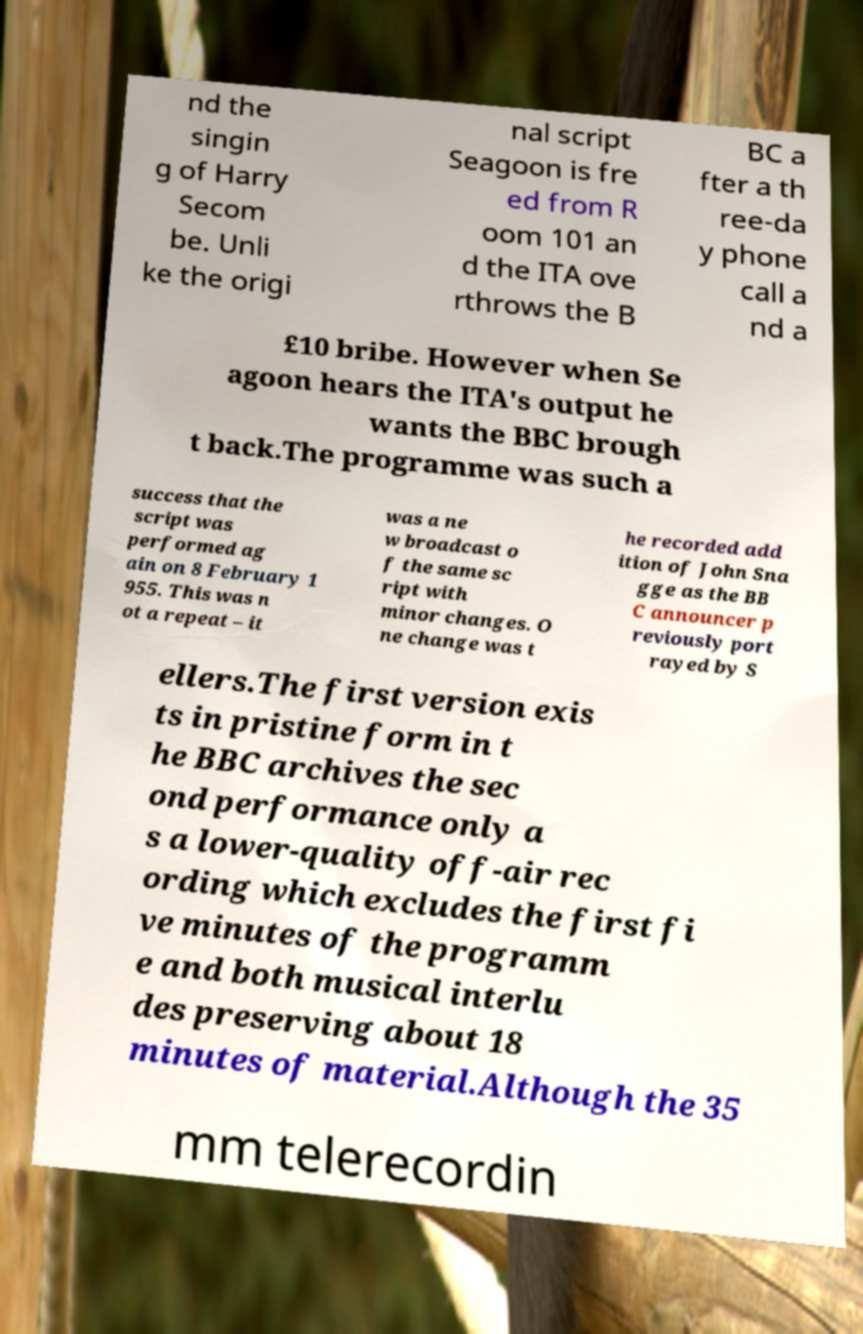I need the written content from this picture converted into text. Can you do that? nd the singin g of Harry Secom be. Unli ke the origi nal script Seagoon is fre ed from R oom 101 an d the ITA ove rthrows the B BC a fter a th ree-da y phone call a nd a £10 bribe. However when Se agoon hears the ITA's output he wants the BBC brough t back.The programme was such a success that the script was performed ag ain on 8 February 1 955. This was n ot a repeat – it was a ne w broadcast o f the same sc ript with minor changes. O ne change was t he recorded add ition of John Sna gge as the BB C announcer p reviously port rayed by S ellers.The first version exis ts in pristine form in t he BBC archives the sec ond performance only a s a lower-quality off-air rec ording which excludes the first fi ve minutes of the programm e and both musical interlu des preserving about 18 minutes of material.Although the 35 mm telerecordin 